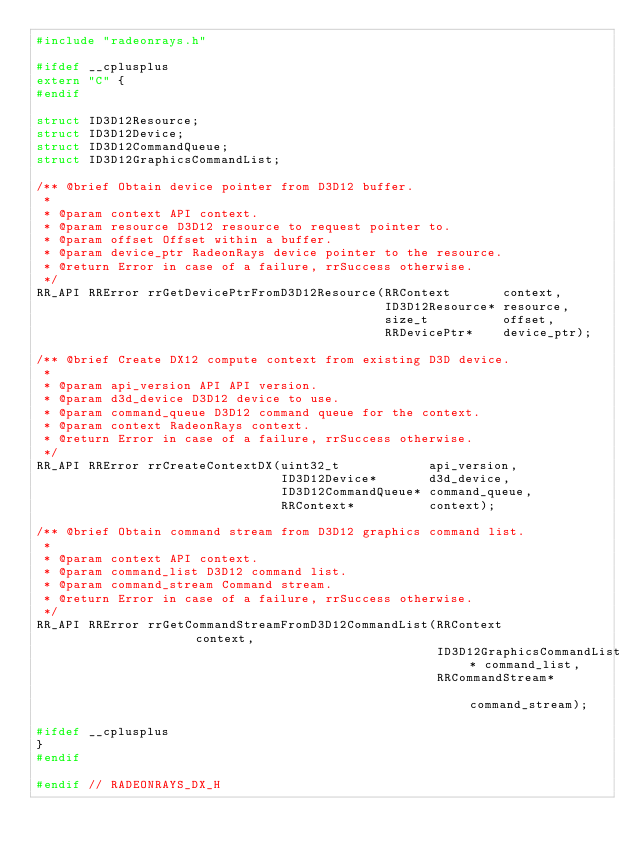Convert code to text. <code><loc_0><loc_0><loc_500><loc_500><_C_>#include "radeonrays.h"

#ifdef __cplusplus
extern "C" {
#endif

struct ID3D12Resource;
struct ID3D12Device;
struct ID3D12CommandQueue;
struct ID3D12GraphicsCommandList;

/** @brief Obtain device pointer from D3D12 buffer.
 *
 * @param context API context.
 * @param resource D3D12 resource to request pointer to.
 * @param offset Offset within a buffer.
 * @param device_ptr RadeonRays device pointer to the resource.
 * @return Error in case of a failure, rrSuccess otherwise.
 */
RR_API RRError rrGetDevicePtrFromD3D12Resource(RRContext       context,
                                               ID3D12Resource* resource,
                                               size_t          offset,
                                               RRDevicePtr*    device_ptr);

/** @brief Create DX12 compute context from existing D3D device.
 *
 * @param api_version API API version.
 * @param d3d_device D3D12 device to use.
 * @param command_queue D3D12 command queue for the context.
 * @param context RadeonRays context.
 * @return Error in case of a failure, rrSuccess otherwise.
 */
RR_API RRError rrCreateContextDX(uint32_t            api_version,
                                 ID3D12Device*       d3d_device,
                                 ID3D12CommandQueue* command_queue,
                                 RRContext*          context);

/** @brief Obtain command stream from D3D12 graphics command list.
 *
 * @param context API context.
 * @param command_list D3D12 command list.
 * @param command_stream Command stream.
 * @return Error in case of a failure, rrSuccess otherwise.
 */
RR_API RRError rrGetCommandStreamFromD3D12CommandList(RRContext                  context,
                                                      ID3D12GraphicsCommandList* command_list,
                                                      RRCommandStream*           command_stream);

#ifdef __cplusplus
}
#endif

#endif // RADEONRAYS_DX_H
</code> 